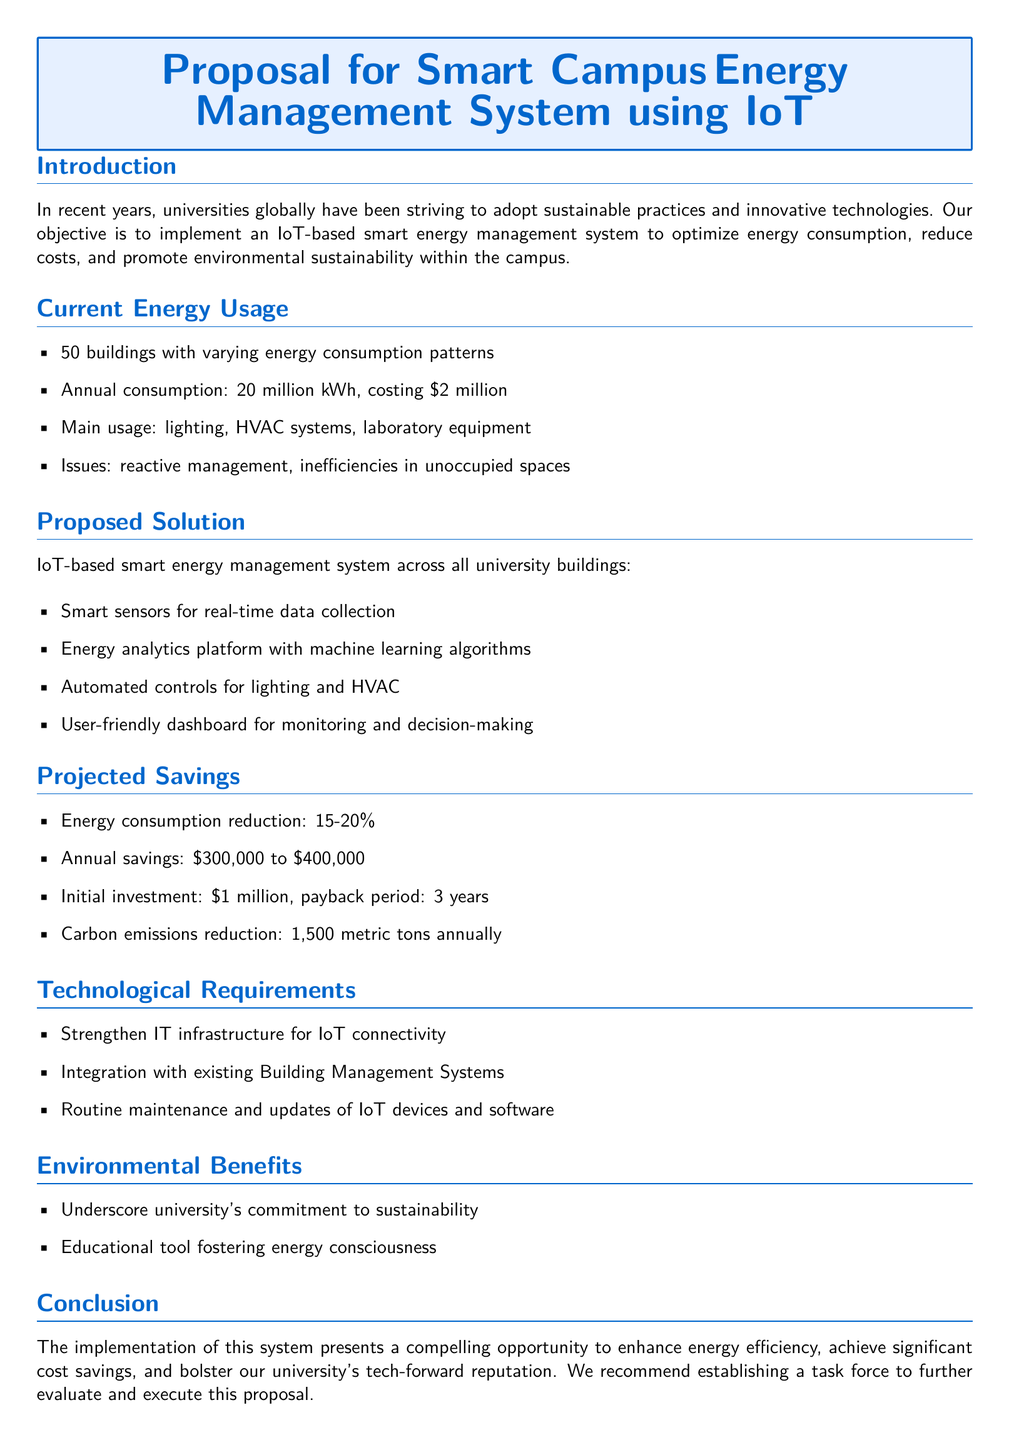What is the annual energy consumption? The document states that the university's annual energy consumption is 20 million kWh.
Answer: 20 million kWh What is the main cost associated with energy consumption? According to the proposal, the annual cost of energy consumption is $2 million.
Answer: $2 million What percentage of energy consumption reduction is projected? The proposal indicates a projected reduction in energy consumption of 15-20%.
Answer: 15-20% How much are the annual savings expected to be? The expected annual savings from the smart energy management system are between $300,000 to $400,000.
Answer: $300,000 to $400,000 What is the initial investment required for the proposed system? The proposal mentions an initial investment of $1 million for implementing the system.
Answer: $1 million How many metric tons of carbon emissions can be reduced annually? The implementation of the system is projected to reduce carbon emissions by 1,500 metric tons annually.
Answer: 1,500 metric tons What issues are identified with current energy management? The proposal notes issues such as reactive management and inefficiencies in unoccupied spaces.
Answer: Reactive management, inefficiencies What is the payback period for the proposed investment? The payback period for the initial investment in the smart energy management system is stated as 3 years.
Answer: 3 years What type of tool will the system serve as for sustainability? The proposal suggests that the system will serve as an educational tool fostering energy consciousness.
Answer: Educational tool 